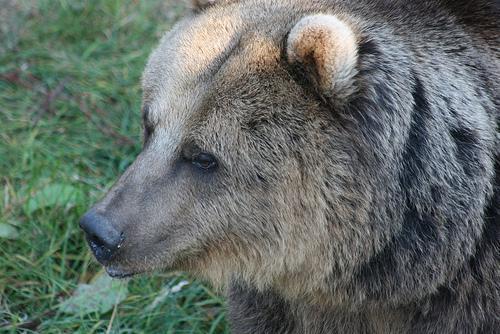How many ears are fully visible?
Give a very brief answer. 1. 